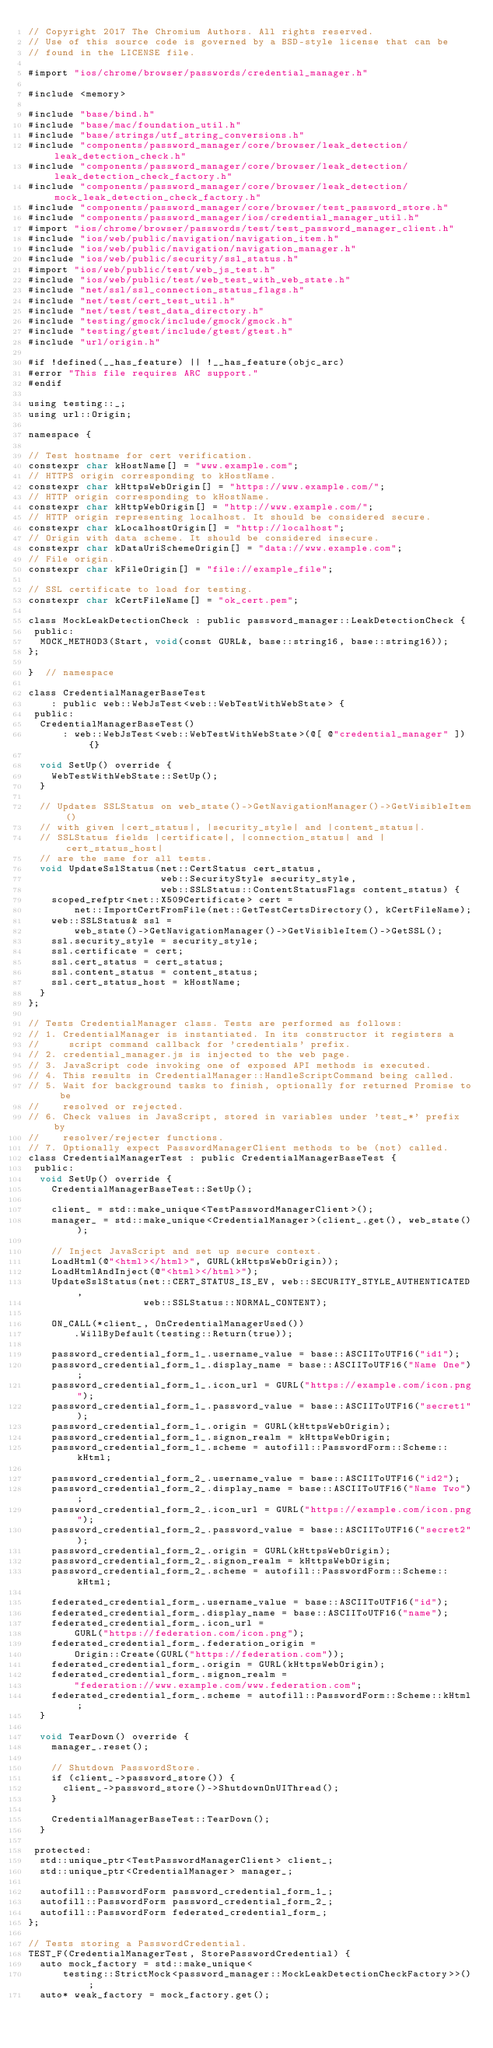<code> <loc_0><loc_0><loc_500><loc_500><_ObjectiveC_>// Copyright 2017 The Chromium Authors. All rights reserved.
// Use of this source code is governed by a BSD-style license that can be
// found in the LICENSE file.

#import "ios/chrome/browser/passwords/credential_manager.h"

#include <memory>

#include "base/bind.h"
#include "base/mac/foundation_util.h"
#include "base/strings/utf_string_conversions.h"
#include "components/password_manager/core/browser/leak_detection/leak_detection_check.h"
#include "components/password_manager/core/browser/leak_detection/leak_detection_check_factory.h"
#include "components/password_manager/core/browser/leak_detection/mock_leak_detection_check_factory.h"
#include "components/password_manager/core/browser/test_password_store.h"
#include "components/password_manager/ios/credential_manager_util.h"
#import "ios/chrome/browser/passwords/test/test_password_manager_client.h"
#include "ios/web/public/navigation/navigation_item.h"
#include "ios/web/public/navigation/navigation_manager.h"
#include "ios/web/public/security/ssl_status.h"
#import "ios/web/public/test/web_js_test.h"
#include "ios/web/public/test/web_test_with_web_state.h"
#include "net/ssl/ssl_connection_status_flags.h"
#include "net/test/cert_test_util.h"
#include "net/test/test_data_directory.h"
#include "testing/gmock/include/gmock/gmock.h"
#include "testing/gtest/include/gtest/gtest.h"
#include "url/origin.h"

#if !defined(__has_feature) || !__has_feature(objc_arc)
#error "This file requires ARC support."
#endif

using testing::_;
using url::Origin;

namespace {

// Test hostname for cert verification.
constexpr char kHostName[] = "www.example.com";
// HTTPS origin corresponding to kHostName.
constexpr char kHttpsWebOrigin[] = "https://www.example.com/";
// HTTP origin corresponding to kHostName.
constexpr char kHttpWebOrigin[] = "http://www.example.com/";
// HTTP origin representing localhost. It should be considered secure.
constexpr char kLocalhostOrigin[] = "http://localhost";
// Origin with data scheme. It should be considered insecure.
constexpr char kDataUriSchemeOrigin[] = "data://www.example.com";
// File origin.
constexpr char kFileOrigin[] = "file://example_file";

// SSL certificate to load for testing.
constexpr char kCertFileName[] = "ok_cert.pem";

class MockLeakDetectionCheck : public password_manager::LeakDetectionCheck {
 public:
  MOCK_METHOD3(Start, void(const GURL&, base::string16, base::string16));
};

}  // namespace

class CredentialManagerBaseTest
    : public web::WebJsTest<web::WebTestWithWebState> {
 public:
  CredentialManagerBaseTest()
      : web::WebJsTest<web::WebTestWithWebState>(@[ @"credential_manager" ]) {}

  void SetUp() override {
    WebTestWithWebState::SetUp();
  }

  // Updates SSLStatus on web_state()->GetNavigationManager()->GetVisibleItem()
  // with given |cert_status|, |security_style| and |content_status|.
  // SSLStatus fields |certificate|, |connection_status| and |cert_status_host|
  // are the same for all tests.
  void UpdateSslStatus(net::CertStatus cert_status,
                       web::SecurityStyle security_style,
                       web::SSLStatus::ContentStatusFlags content_status) {
    scoped_refptr<net::X509Certificate> cert =
        net::ImportCertFromFile(net::GetTestCertsDirectory(), kCertFileName);
    web::SSLStatus& ssl =
        web_state()->GetNavigationManager()->GetVisibleItem()->GetSSL();
    ssl.security_style = security_style;
    ssl.certificate = cert;
    ssl.cert_status = cert_status;
    ssl.content_status = content_status;
    ssl.cert_status_host = kHostName;
  }
};

// Tests CredentialManager class. Tests are performed as follows:
// 1. CredentialManager is instantiated. In its constructor it registers a
//     script command callback for 'credentials' prefix.
// 2. credential_manager.js is injected to the web page.
// 3. JavaScript code invoking one of exposed API methods is executed.
// 4. This results in CredentialManager::HandleScriptCommand being called.
// 5. Wait for background tasks to finish, optionally for returned Promise to be
//    resolved or rejected.
// 6. Check values in JavaScript, stored in variables under 'test_*' prefix by
//    resolver/rejecter functions.
// 7. Optionally expect PasswordManagerClient methods to be (not) called.
class CredentialManagerTest : public CredentialManagerBaseTest {
 public:
  void SetUp() override {
    CredentialManagerBaseTest::SetUp();

    client_ = std::make_unique<TestPasswordManagerClient>();
    manager_ = std::make_unique<CredentialManager>(client_.get(), web_state());

    // Inject JavaScript and set up secure context.
    LoadHtml(@"<html></html>", GURL(kHttpsWebOrigin));
    LoadHtmlAndInject(@"<html></html>");
    UpdateSslStatus(net::CERT_STATUS_IS_EV, web::SECURITY_STYLE_AUTHENTICATED,
                    web::SSLStatus::NORMAL_CONTENT);

    ON_CALL(*client_, OnCredentialManagerUsed())
        .WillByDefault(testing::Return(true));

    password_credential_form_1_.username_value = base::ASCIIToUTF16("id1");
    password_credential_form_1_.display_name = base::ASCIIToUTF16("Name One");
    password_credential_form_1_.icon_url = GURL("https://example.com/icon.png");
    password_credential_form_1_.password_value = base::ASCIIToUTF16("secret1");
    password_credential_form_1_.origin = GURL(kHttpsWebOrigin);
    password_credential_form_1_.signon_realm = kHttpsWebOrigin;
    password_credential_form_1_.scheme = autofill::PasswordForm::Scheme::kHtml;

    password_credential_form_2_.username_value = base::ASCIIToUTF16("id2");
    password_credential_form_2_.display_name = base::ASCIIToUTF16("Name Two");
    password_credential_form_2_.icon_url = GURL("https://example.com/icon.png");
    password_credential_form_2_.password_value = base::ASCIIToUTF16("secret2");
    password_credential_form_2_.origin = GURL(kHttpsWebOrigin);
    password_credential_form_2_.signon_realm = kHttpsWebOrigin;
    password_credential_form_2_.scheme = autofill::PasswordForm::Scheme::kHtml;

    federated_credential_form_.username_value = base::ASCIIToUTF16("id");
    federated_credential_form_.display_name = base::ASCIIToUTF16("name");
    federated_credential_form_.icon_url =
        GURL("https://federation.com/icon.png");
    federated_credential_form_.federation_origin =
        Origin::Create(GURL("https://federation.com"));
    federated_credential_form_.origin = GURL(kHttpsWebOrigin);
    federated_credential_form_.signon_realm =
        "federation://www.example.com/www.federation.com";
    federated_credential_form_.scheme = autofill::PasswordForm::Scheme::kHtml;
  }

  void TearDown() override {
    manager_.reset();

    // Shutdown PasswordStore.
    if (client_->password_store()) {
      client_->password_store()->ShutdownOnUIThread();
    }

    CredentialManagerBaseTest::TearDown();
  }

 protected:
  std::unique_ptr<TestPasswordManagerClient> client_;
  std::unique_ptr<CredentialManager> manager_;

  autofill::PasswordForm password_credential_form_1_;
  autofill::PasswordForm password_credential_form_2_;
  autofill::PasswordForm federated_credential_form_;
};

// Tests storing a PasswordCredential.
TEST_F(CredentialManagerTest, StorePasswordCredential) {
  auto mock_factory = std::make_unique<
      testing::StrictMock<password_manager::MockLeakDetectionCheckFactory>>();
  auto* weak_factory = mock_factory.get();</code> 